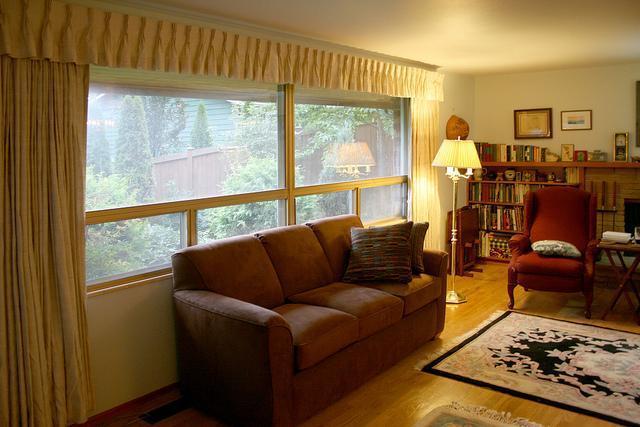How many chairs can be seen?
Give a very brief answer. 1. How many couches are visible?
Give a very brief answer. 1. 